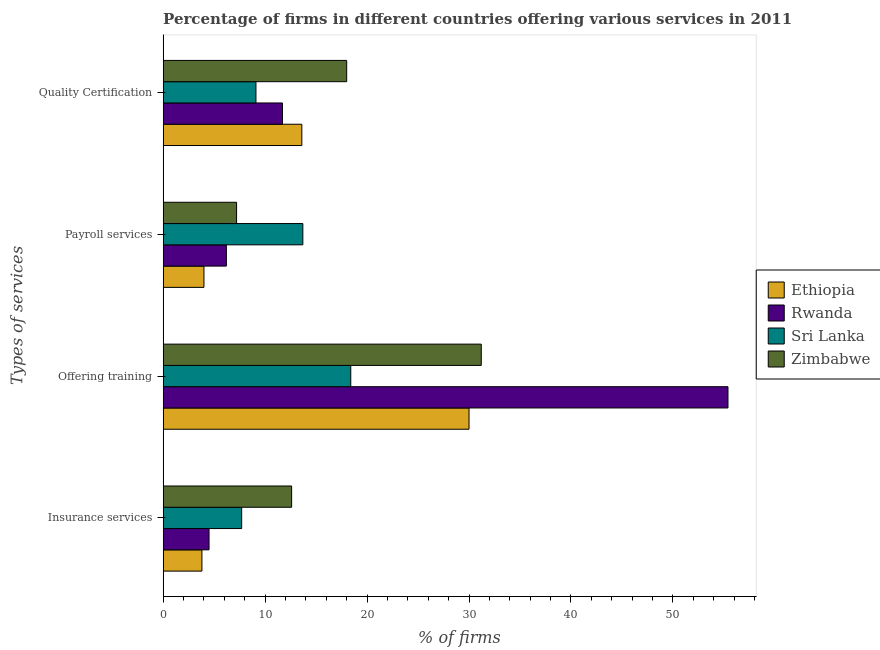How many groups of bars are there?
Keep it short and to the point. 4. Are the number of bars on each tick of the Y-axis equal?
Give a very brief answer. Yes. How many bars are there on the 2nd tick from the top?
Your answer should be compact. 4. What is the label of the 3rd group of bars from the top?
Your answer should be compact. Offering training. Across all countries, what is the maximum percentage of firms offering payroll services?
Offer a terse response. 13.7. Across all countries, what is the minimum percentage of firms offering payroll services?
Provide a short and direct response. 4. In which country was the percentage of firms offering quality certification maximum?
Provide a succinct answer. Zimbabwe. In which country was the percentage of firms offering payroll services minimum?
Your response must be concise. Ethiopia. What is the total percentage of firms offering training in the graph?
Provide a succinct answer. 135. What is the difference between the percentage of firms offering insurance services in Rwanda and that in Zimbabwe?
Keep it short and to the point. -8.1. What is the difference between the percentage of firms offering payroll services in Ethiopia and the percentage of firms offering quality certification in Sri Lanka?
Offer a very short reply. -5.1. What is the difference between the percentage of firms offering quality certification and percentage of firms offering payroll services in Zimbabwe?
Your response must be concise. 10.8. In how many countries, is the percentage of firms offering insurance services greater than 42 %?
Keep it short and to the point. 0. What is the ratio of the percentage of firms offering quality certification in Sri Lanka to that in Zimbabwe?
Your response must be concise. 0.51. Is the percentage of firms offering quality certification in Zimbabwe less than that in Ethiopia?
Make the answer very short. No. What is the difference between the highest and the second highest percentage of firms offering insurance services?
Make the answer very short. 4.9. What is the difference between the highest and the lowest percentage of firms offering insurance services?
Ensure brevity in your answer.  8.8. Is it the case that in every country, the sum of the percentage of firms offering payroll services and percentage of firms offering quality certification is greater than the sum of percentage of firms offering insurance services and percentage of firms offering training?
Ensure brevity in your answer.  Yes. What does the 3rd bar from the top in Quality Certification represents?
Provide a succinct answer. Rwanda. What does the 4th bar from the bottom in Quality Certification represents?
Provide a succinct answer. Zimbabwe. How many bars are there?
Your response must be concise. 16. Are all the bars in the graph horizontal?
Offer a terse response. Yes. How many countries are there in the graph?
Provide a short and direct response. 4. What is the difference between two consecutive major ticks on the X-axis?
Ensure brevity in your answer.  10. Are the values on the major ticks of X-axis written in scientific E-notation?
Offer a very short reply. No. Does the graph contain any zero values?
Keep it short and to the point. No. How many legend labels are there?
Your answer should be very brief. 4. How are the legend labels stacked?
Give a very brief answer. Vertical. What is the title of the graph?
Offer a terse response. Percentage of firms in different countries offering various services in 2011. Does "South Africa" appear as one of the legend labels in the graph?
Make the answer very short. No. What is the label or title of the X-axis?
Offer a very short reply. % of firms. What is the label or title of the Y-axis?
Your answer should be compact. Types of services. What is the % of firms of Rwanda in Insurance services?
Provide a short and direct response. 4.5. What is the % of firms of Zimbabwe in Insurance services?
Ensure brevity in your answer.  12.6. What is the % of firms in Ethiopia in Offering training?
Provide a succinct answer. 30. What is the % of firms of Rwanda in Offering training?
Give a very brief answer. 55.4. What is the % of firms of Zimbabwe in Offering training?
Provide a short and direct response. 31.2. What is the % of firms of Ethiopia in Payroll services?
Your answer should be very brief. 4. What is the % of firms of Rwanda in Payroll services?
Give a very brief answer. 6.2. What is the % of firms in Zimbabwe in Payroll services?
Offer a terse response. 7.2. What is the % of firms of Sri Lanka in Quality Certification?
Make the answer very short. 9.1. Across all Types of services, what is the maximum % of firms of Rwanda?
Offer a very short reply. 55.4. Across all Types of services, what is the maximum % of firms of Zimbabwe?
Provide a succinct answer. 31.2. Across all Types of services, what is the minimum % of firms of Ethiopia?
Give a very brief answer. 3.8. Across all Types of services, what is the minimum % of firms of Zimbabwe?
Make the answer very short. 7.2. What is the total % of firms of Ethiopia in the graph?
Provide a succinct answer. 51.4. What is the total % of firms in Rwanda in the graph?
Your response must be concise. 77.8. What is the total % of firms in Sri Lanka in the graph?
Provide a short and direct response. 48.9. What is the difference between the % of firms of Ethiopia in Insurance services and that in Offering training?
Give a very brief answer. -26.2. What is the difference between the % of firms of Rwanda in Insurance services and that in Offering training?
Your answer should be compact. -50.9. What is the difference between the % of firms of Sri Lanka in Insurance services and that in Offering training?
Make the answer very short. -10.7. What is the difference between the % of firms of Zimbabwe in Insurance services and that in Offering training?
Keep it short and to the point. -18.6. What is the difference between the % of firms in Rwanda in Insurance services and that in Payroll services?
Your response must be concise. -1.7. What is the difference between the % of firms of Ethiopia in Insurance services and that in Quality Certification?
Offer a terse response. -9.8. What is the difference between the % of firms of Rwanda in Insurance services and that in Quality Certification?
Ensure brevity in your answer.  -7.2. What is the difference between the % of firms in Zimbabwe in Insurance services and that in Quality Certification?
Your answer should be very brief. -5.4. What is the difference between the % of firms of Rwanda in Offering training and that in Payroll services?
Your answer should be very brief. 49.2. What is the difference between the % of firms of Sri Lanka in Offering training and that in Payroll services?
Your answer should be compact. 4.7. What is the difference between the % of firms of Zimbabwe in Offering training and that in Payroll services?
Provide a succinct answer. 24. What is the difference between the % of firms of Rwanda in Offering training and that in Quality Certification?
Make the answer very short. 43.7. What is the difference between the % of firms of Zimbabwe in Offering training and that in Quality Certification?
Give a very brief answer. 13.2. What is the difference between the % of firms of Ethiopia in Payroll services and that in Quality Certification?
Your answer should be very brief. -9.6. What is the difference between the % of firms of Rwanda in Payroll services and that in Quality Certification?
Your answer should be very brief. -5.5. What is the difference between the % of firms of Zimbabwe in Payroll services and that in Quality Certification?
Provide a short and direct response. -10.8. What is the difference between the % of firms in Ethiopia in Insurance services and the % of firms in Rwanda in Offering training?
Provide a short and direct response. -51.6. What is the difference between the % of firms of Ethiopia in Insurance services and the % of firms of Sri Lanka in Offering training?
Your answer should be very brief. -14.6. What is the difference between the % of firms in Ethiopia in Insurance services and the % of firms in Zimbabwe in Offering training?
Keep it short and to the point. -27.4. What is the difference between the % of firms in Rwanda in Insurance services and the % of firms in Zimbabwe in Offering training?
Offer a very short reply. -26.7. What is the difference between the % of firms in Sri Lanka in Insurance services and the % of firms in Zimbabwe in Offering training?
Your answer should be very brief. -23.5. What is the difference between the % of firms of Ethiopia in Insurance services and the % of firms of Rwanda in Payroll services?
Make the answer very short. -2.4. What is the difference between the % of firms of Ethiopia in Insurance services and the % of firms of Zimbabwe in Payroll services?
Your answer should be very brief. -3.4. What is the difference between the % of firms of Rwanda in Insurance services and the % of firms of Sri Lanka in Payroll services?
Your answer should be very brief. -9.2. What is the difference between the % of firms in Rwanda in Insurance services and the % of firms in Zimbabwe in Payroll services?
Your response must be concise. -2.7. What is the difference between the % of firms in Sri Lanka in Insurance services and the % of firms in Zimbabwe in Payroll services?
Provide a short and direct response. 0.5. What is the difference between the % of firms in Ethiopia in Insurance services and the % of firms in Zimbabwe in Quality Certification?
Offer a terse response. -14.2. What is the difference between the % of firms of Rwanda in Insurance services and the % of firms of Zimbabwe in Quality Certification?
Provide a succinct answer. -13.5. What is the difference between the % of firms in Sri Lanka in Insurance services and the % of firms in Zimbabwe in Quality Certification?
Your answer should be very brief. -10.3. What is the difference between the % of firms of Ethiopia in Offering training and the % of firms of Rwanda in Payroll services?
Keep it short and to the point. 23.8. What is the difference between the % of firms in Ethiopia in Offering training and the % of firms in Zimbabwe in Payroll services?
Your answer should be compact. 22.8. What is the difference between the % of firms of Rwanda in Offering training and the % of firms of Sri Lanka in Payroll services?
Offer a terse response. 41.7. What is the difference between the % of firms of Rwanda in Offering training and the % of firms of Zimbabwe in Payroll services?
Make the answer very short. 48.2. What is the difference between the % of firms in Sri Lanka in Offering training and the % of firms in Zimbabwe in Payroll services?
Give a very brief answer. 11.2. What is the difference between the % of firms of Ethiopia in Offering training and the % of firms of Rwanda in Quality Certification?
Your answer should be compact. 18.3. What is the difference between the % of firms in Ethiopia in Offering training and the % of firms in Sri Lanka in Quality Certification?
Give a very brief answer. 20.9. What is the difference between the % of firms of Ethiopia in Offering training and the % of firms of Zimbabwe in Quality Certification?
Offer a terse response. 12. What is the difference between the % of firms in Rwanda in Offering training and the % of firms in Sri Lanka in Quality Certification?
Offer a very short reply. 46.3. What is the difference between the % of firms in Rwanda in Offering training and the % of firms in Zimbabwe in Quality Certification?
Offer a very short reply. 37.4. What is the difference between the % of firms of Sri Lanka in Offering training and the % of firms of Zimbabwe in Quality Certification?
Keep it short and to the point. 0.4. What is the difference between the % of firms of Ethiopia in Payroll services and the % of firms of Rwanda in Quality Certification?
Offer a very short reply. -7.7. What is the difference between the % of firms of Ethiopia in Payroll services and the % of firms of Zimbabwe in Quality Certification?
Make the answer very short. -14. What is the difference between the % of firms of Rwanda in Payroll services and the % of firms of Sri Lanka in Quality Certification?
Your answer should be very brief. -2.9. What is the average % of firms in Ethiopia per Types of services?
Your answer should be very brief. 12.85. What is the average % of firms of Rwanda per Types of services?
Your answer should be very brief. 19.45. What is the average % of firms of Sri Lanka per Types of services?
Offer a terse response. 12.22. What is the average % of firms of Zimbabwe per Types of services?
Keep it short and to the point. 17.25. What is the difference between the % of firms in Ethiopia and % of firms in Sri Lanka in Insurance services?
Make the answer very short. -3.9. What is the difference between the % of firms of Ethiopia and % of firms of Zimbabwe in Insurance services?
Ensure brevity in your answer.  -8.8. What is the difference between the % of firms of Sri Lanka and % of firms of Zimbabwe in Insurance services?
Ensure brevity in your answer.  -4.9. What is the difference between the % of firms in Ethiopia and % of firms in Rwanda in Offering training?
Your answer should be very brief. -25.4. What is the difference between the % of firms in Ethiopia and % of firms in Sri Lanka in Offering training?
Give a very brief answer. 11.6. What is the difference between the % of firms in Ethiopia and % of firms in Zimbabwe in Offering training?
Your response must be concise. -1.2. What is the difference between the % of firms of Rwanda and % of firms of Zimbabwe in Offering training?
Offer a terse response. 24.2. What is the difference between the % of firms in Sri Lanka and % of firms in Zimbabwe in Offering training?
Provide a short and direct response. -12.8. What is the difference between the % of firms of Ethiopia and % of firms of Rwanda in Quality Certification?
Provide a short and direct response. 1.9. What is the difference between the % of firms of Ethiopia and % of firms of Sri Lanka in Quality Certification?
Offer a very short reply. 4.5. What is the difference between the % of firms of Rwanda and % of firms of Sri Lanka in Quality Certification?
Make the answer very short. 2.6. What is the ratio of the % of firms of Ethiopia in Insurance services to that in Offering training?
Ensure brevity in your answer.  0.13. What is the ratio of the % of firms in Rwanda in Insurance services to that in Offering training?
Provide a short and direct response. 0.08. What is the ratio of the % of firms in Sri Lanka in Insurance services to that in Offering training?
Make the answer very short. 0.42. What is the ratio of the % of firms of Zimbabwe in Insurance services to that in Offering training?
Offer a terse response. 0.4. What is the ratio of the % of firms in Rwanda in Insurance services to that in Payroll services?
Your answer should be compact. 0.73. What is the ratio of the % of firms in Sri Lanka in Insurance services to that in Payroll services?
Offer a very short reply. 0.56. What is the ratio of the % of firms in Zimbabwe in Insurance services to that in Payroll services?
Keep it short and to the point. 1.75. What is the ratio of the % of firms in Ethiopia in Insurance services to that in Quality Certification?
Offer a very short reply. 0.28. What is the ratio of the % of firms of Rwanda in Insurance services to that in Quality Certification?
Provide a short and direct response. 0.38. What is the ratio of the % of firms of Sri Lanka in Insurance services to that in Quality Certification?
Offer a very short reply. 0.85. What is the ratio of the % of firms in Ethiopia in Offering training to that in Payroll services?
Make the answer very short. 7.5. What is the ratio of the % of firms in Rwanda in Offering training to that in Payroll services?
Provide a succinct answer. 8.94. What is the ratio of the % of firms in Sri Lanka in Offering training to that in Payroll services?
Offer a very short reply. 1.34. What is the ratio of the % of firms in Zimbabwe in Offering training to that in Payroll services?
Keep it short and to the point. 4.33. What is the ratio of the % of firms of Ethiopia in Offering training to that in Quality Certification?
Provide a succinct answer. 2.21. What is the ratio of the % of firms of Rwanda in Offering training to that in Quality Certification?
Offer a terse response. 4.74. What is the ratio of the % of firms in Sri Lanka in Offering training to that in Quality Certification?
Offer a very short reply. 2.02. What is the ratio of the % of firms in Zimbabwe in Offering training to that in Quality Certification?
Your answer should be very brief. 1.73. What is the ratio of the % of firms in Ethiopia in Payroll services to that in Quality Certification?
Provide a succinct answer. 0.29. What is the ratio of the % of firms in Rwanda in Payroll services to that in Quality Certification?
Make the answer very short. 0.53. What is the ratio of the % of firms in Sri Lanka in Payroll services to that in Quality Certification?
Your answer should be very brief. 1.51. What is the ratio of the % of firms of Zimbabwe in Payroll services to that in Quality Certification?
Your answer should be compact. 0.4. What is the difference between the highest and the second highest % of firms of Rwanda?
Keep it short and to the point. 43.7. What is the difference between the highest and the second highest % of firms in Zimbabwe?
Keep it short and to the point. 13.2. What is the difference between the highest and the lowest % of firms of Ethiopia?
Ensure brevity in your answer.  26.2. What is the difference between the highest and the lowest % of firms in Rwanda?
Give a very brief answer. 50.9. 